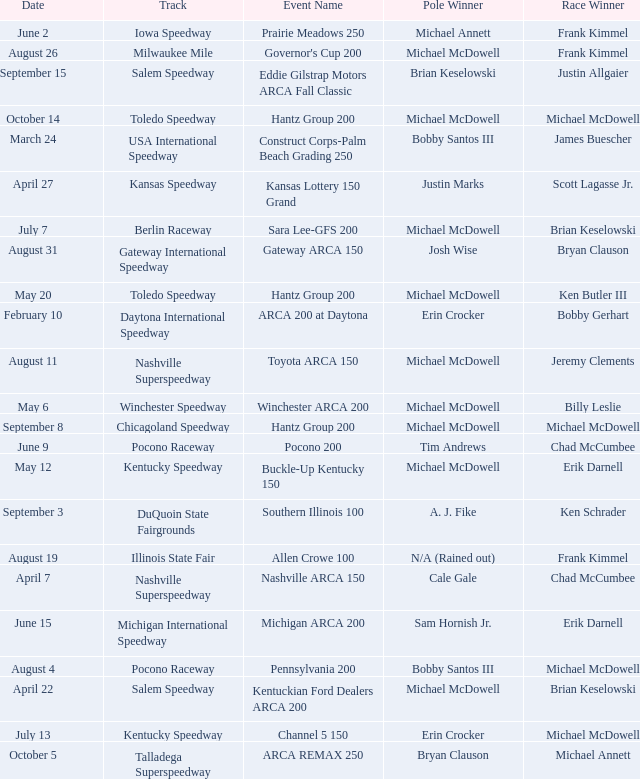Tell me the track for scott lagasse jr. Kansas Speedway. 